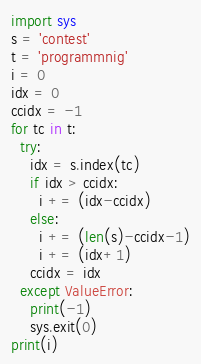Convert code to text. <code><loc_0><loc_0><loc_500><loc_500><_Python_>import sys
s = 'contest'
t = 'programmnig'
i = 0
idx = 0
ccidx = -1
for tc in t:
  try:
    idx = s.index(tc)
    if idx > ccidx:
      i += (idx-ccidx)
    else:
      i += (len(s)-ccidx-1)
      i += (idx+1)
    ccidx = idx
  except ValueError:
    print(-1)
    sys.exit(0)
print(i)
</code> 